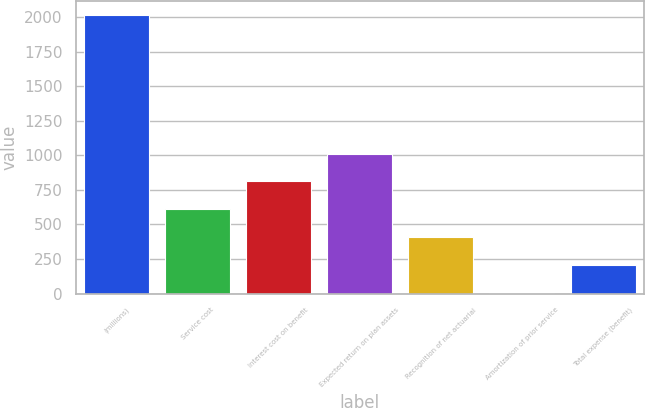Convert chart to OTSL. <chart><loc_0><loc_0><loc_500><loc_500><bar_chart><fcel>(millions)<fcel>Service cost<fcel>Interest cost on benefit<fcel>Expected return on plan assets<fcel>Recognition of net actuarial<fcel>Amortization of prior service<fcel>Total expense (benefit)<nl><fcel>2017<fcel>609.86<fcel>810.88<fcel>1011.9<fcel>408.84<fcel>6.8<fcel>207.82<nl></chart> 